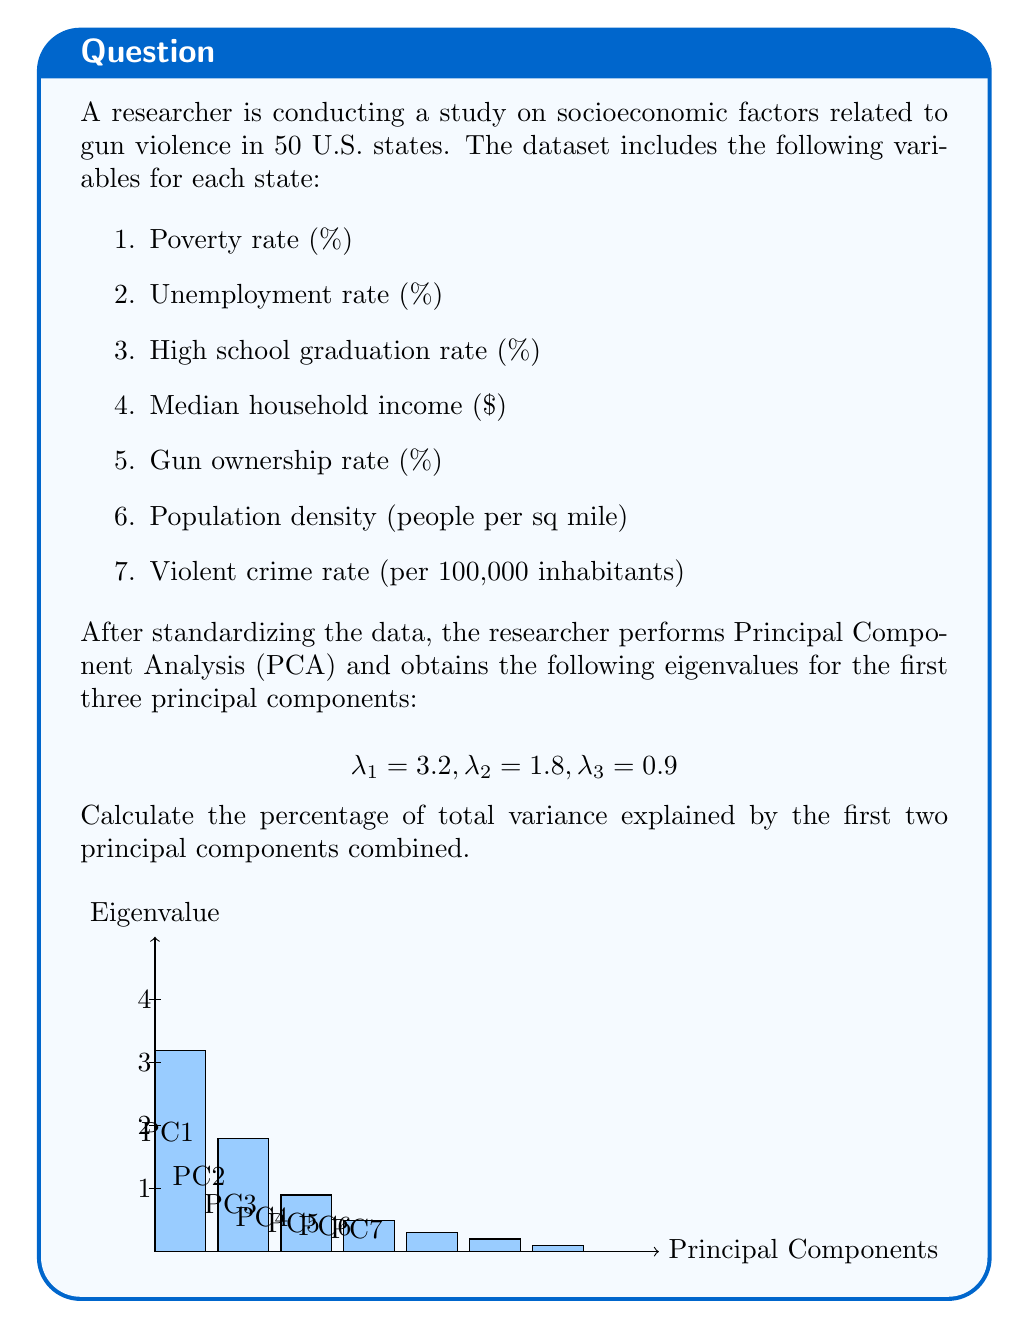Could you help me with this problem? To calculate the percentage of total variance explained by the first two principal components, we need to follow these steps:

1. Calculate the total variance:
   The total variance is the sum of all eigenvalues. In PCA, the number of eigenvalues equals the number of original variables. We're given the first three, so we need to assume the rest sum up to complete 7 total (matching our 7 variables).
   
   Let $\lambda_t$ be the total variance:
   $$\lambda_t = 3.2 + 1.8 + 0.9 + (7 - 3.2 - 1.8 - 0.9) = 7$$

2. Calculate the variance explained by the first two principal components:
   $$\lambda_{1,2} = \lambda_1 + \lambda_2 = 3.2 + 1.8 = 5$$

3. Calculate the percentage of variance explained:
   $$\text{Percentage} = \frac{\lambda_{1,2}}{\lambda_t} \times 100\% = \frac{5}{7} \times 100\% \approx 71.43\%$$

Therefore, the first two principal components explain approximately 71.43% of the total variance in the dataset.

This high percentage indicates that these two components capture a significant amount of the variation in the socioeconomic factors related to gun violence, which could be valuable for developing evidence-based public health policies.
Answer: 71.43% 